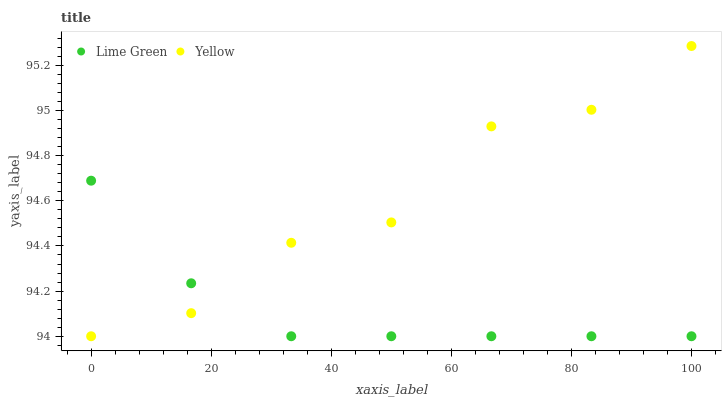Does Lime Green have the minimum area under the curve?
Answer yes or no. Yes. Does Yellow have the maximum area under the curve?
Answer yes or no. Yes. Does Yellow have the minimum area under the curve?
Answer yes or no. No. Is Lime Green the smoothest?
Answer yes or no. Yes. Is Yellow the roughest?
Answer yes or no. Yes. Is Yellow the smoothest?
Answer yes or no. No. Does Lime Green have the lowest value?
Answer yes or no. Yes. Does Yellow have the highest value?
Answer yes or no. Yes. Does Yellow intersect Lime Green?
Answer yes or no. Yes. Is Yellow less than Lime Green?
Answer yes or no. No. Is Yellow greater than Lime Green?
Answer yes or no. No. 